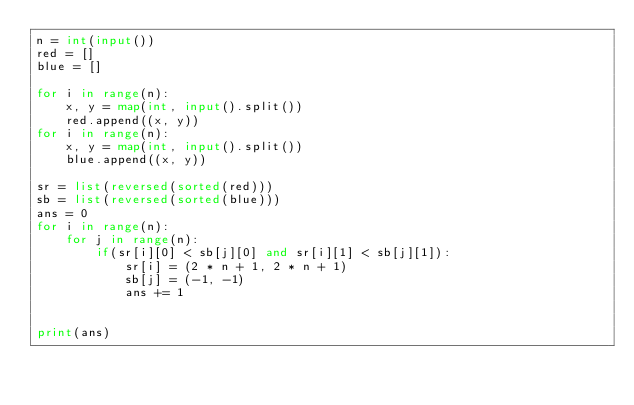Convert code to text. <code><loc_0><loc_0><loc_500><loc_500><_Python_>n = int(input())
red = []
blue = []

for i in range(n):
    x, y = map(int, input().split())
    red.append((x, y))
for i in range(n):
    x, y = map(int, input().split())
    blue.append((x, y))

sr = list(reversed(sorted(red)))
sb = list(reversed(sorted(blue)))
ans = 0
for i in range(n):
    for j in range(n):
        if(sr[i][0] < sb[j][0] and sr[i][1] < sb[j][1]):
            sr[i] = (2 * n + 1, 2 * n + 1)
            sb[j] = (-1, -1)
            ans += 1


print(ans)</code> 